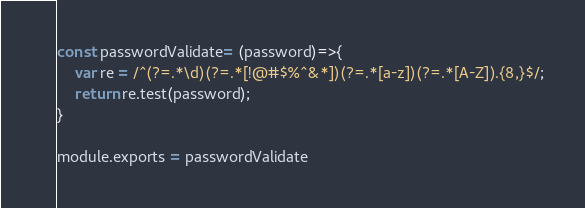<code> <loc_0><loc_0><loc_500><loc_500><_JavaScript_>const passwordValidate= (password)=>{
    var re = /^(?=.*\d)(?=.*[!@#$%^&*])(?=.*[a-z])(?=.*[A-Z]).{8,}$/;
    return re.test(password);
}

module.exports = passwordValidate</code> 